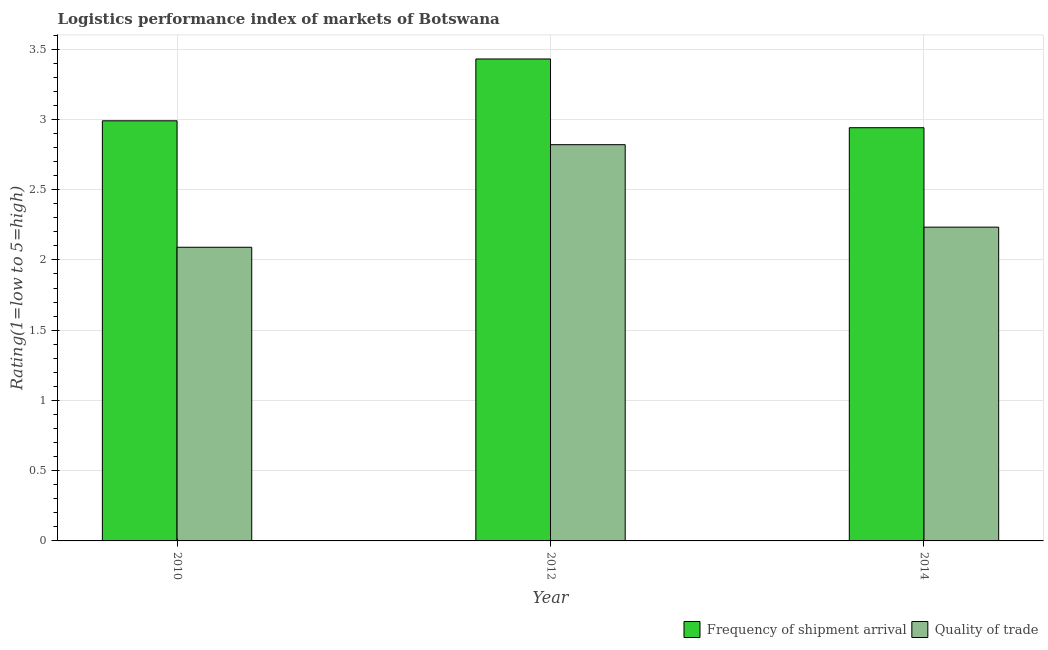How many different coloured bars are there?
Provide a succinct answer. 2. Are the number of bars per tick equal to the number of legend labels?
Your answer should be compact. Yes. Are the number of bars on each tick of the X-axis equal?
Offer a terse response. Yes. How many bars are there on the 3rd tick from the left?
Ensure brevity in your answer.  2. What is the label of the 2nd group of bars from the left?
Make the answer very short. 2012. In how many cases, is the number of bars for a given year not equal to the number of legend labels?
Provide a short and direct response. 0. What is the lpi of frequency of shipment arrival in 2014?
Your answer should be very brief. 2.94. Across all years, what is the maximum lpi of frequency of shipment arrival?
Your response must be concise. 3.43. Across all years, what is the minimum lpi of frequency of shipment arrival?
Your answer should be very brief. 2.94. What is the total lpi of frequency of shipment arrival in the graph?
Make the answer very short. 9.36. What is the difference between the lpi of frequency of shipment arrival in 2012 and that in 2014?
Provide a succinct answer. 0.49. What is the difference between the lpi quality of trade in 2012 and the lpi of frequency of shipment arrival in 2010?
Give a very brief answer. 0.73. What is the average lpi of frequency of shipment arrival per year?
Provide a short and direct response. 3.12. In the year 2014, what is the difference between the lpi of frequency of shipment arrival and lpi quality of trade?
Ensure brevity in your answer.  0. In how many years, is the lpi of frequency of shipment arrival greater than 3?
Make the answer very short. 1. What is the ratio of the lpi quality of trade in 2012 to that in 2014?
Ensure brevity in your answer.  1.26. Is the lpi of frequency of shipment arrival in 2012 less than that in 2014?
Offer a very short reply. No. Is the difference between the lpi of frequency of shipment arrival in 2010 and 2012 greater than the difference between the lpi quality of trade in 2010 and 2012?
Make the answer very short. No. What is the difference between the highest and the second highest lpi quality of trade?
Give a very brief answer. 0.59. What is the difference between the highest and the lowest lpi quality of trade?
Your response must be concise. 0.73. In how many years, is the lpi quality of trade greater than the average lpi quality of trade taken over all years?
Keep it short and to the point. 1. What does the 2nd bar from the left in 2014 represents?
Your response must be concise. Quality of trade. What does the 2nd bar from the right in 2010 represents?
Make the answer very short. Frequency of shipment arrival. How many bars are there?
Offer a very short reply. 6. How many years are there in the graph?
Make the answer very short. 3. How many legend labels are there?
Provide a succinct answer. 2. What is the title of the graph?
Keep it short and to the point. Logistics performance index of markets of Botswana. What is the label or title of the Y-axis?
Your answer should be compact. Rating(1=low to 5=high). What is the Rating(1=low to 5=high) of Frequency of shipment arrival in 2010?
Offer a very short reply. 2.99. What is the Rating(1=low to 5=high) in Quality of trade in 2010?
Offer a very short reply. 2.09. What is the Rating(1=low to 5=high) in Frequency of shipment arrival in 2012?
Ensure brevity in your answer.  3.43. What is the Rating(1=low to 5=high) in Quality of trade in 2012?
Ensure brevity in your answer.  2.82. What is the Rating(1=low to 5=high) in Frequency of shipment arrival in 2014?
Your answer should be compact. 2.94. What is the Rating(1=low to 5=high) in Quality of trade in 2014?
Ensure brevity in your answer.  2.23. Across all years, what is the maximum Rating(1=low to 5=high) in Frequency of shipment arrival?
Make the answer very short. 3.43. Across all years, what is the maximum Rating(1=low to 5=high) in Quality of trade?
Give a very brief answer. 2.82. Across all years, what is the minimum Rating(1=low to 5=high) in Frequency of shipment arrival?
Offer a very short reply. 2.94. Across all years, what is the minimum Rating(1=low to 5=high) in Quality of trade?
Your answer should be very brief. 2.09. What is the total Rating(1=low to 5=high) in Frequency of shipment arrival in the graph?
Offer a terse response. 9.36. What is the total Rating(1=low to 5=high) of Quality of trade in the graph?
Your response must be concise. 7.14. What is the difference between the Rating(1=low to 5=high) of Frequency of shipment arrival in 2010 and that in 2012?
Provide a short and direct response. -0.44. What is the difference between the Rating(1=low to 5=high) in Quality of trade in 2010 and that in 2012?
Make the answer very short. -0.73. What is the difference between the Rating(1=low to 5=high) in Frequency of shipment arrival in 2010 and that in 2014?
Your answer should be very brief. 0.05. What is the difference between the Rating(1=low to 5=high) of Quality of trade in 2010 and that in 2014?
Provide a short and direct response. -0.14. What is the difference between the Rating(1=low to 5=high) of Frequency of shipment arrival in 2012 and that in 2014?
Your answer should be compact. 0.49. What is the difference between the Rating(1=low to 5=high) of Quality of trade in 2012 and that in 2014?
Provide a short and direct response. 0.59. What is the difference between the Rating(1=low to 5=high) in Frequency of shipment arrival in 2010 and the Rating(1=low to 5=high) in Quality of trade in 2012?
Your answer should be compact. 0.17. What is the difference between the Rating(1=low to 5=high) of Frequency of shipment arrival in 2010 and the Rating(1=low to 5=high) of Quality of trade in 2014?
Give a very brief answer. 0.76. What is the difference between the Rating(1=low to 5=high) in Frequency of shipment arrival in 2012 and the Rating(1=low to 5=high) in Quality of trade in 2014?
Your answer should be very brief. 1.2. What is the average Rating(1=low to 5=high) of Frequency of shipment arrival per year?
Ensure brevity in your answer.  3.12. What is the average Rating(1=low to 5=high) in Quality of trade per year?
Provide a succinct answer. 2.38. In the year 2010, what is the difference between the Rating(1=low to 5=high) in Frequency of shipment arrival and Rating(1=low to 5=high) in Quality of trade?
Provide a succinct answer. 0.9. In the year 2012, what is the difference between the Rating(1=low to 5=high) of Frequency of shipment arrival and Rating(1=low to 5=high) of Quality of trade?
Offer a very short reply. 0.61. In the year 2014, what is the difference between the Rating(1=low to 5=high) of Frequency of shipment arrival and Rating(1=low to 5=high) of Quality of trade?
Your answer should be compact. 0.71. What is the ratio of the Rating(1=low to 5=high) of Frequency of shipment arrival in 2010 to that in 2012?
Provide a succinct answer. 0.87. What is the ratio of the Rating(1=low to 5=high) in Quality of trade in 2010 to that in 2012?
Offer a terse response. 0.74. What is the ratio of the Rating(1=low to 5=high) of Frequency of shipment arrival in 2010 to that in 2014?
Provide a succinct answer. 1.02. What is the ratio of the Rating(1=low to 5=high) of Quality of trade in 2010 to that in 2014?
Offer a very short reply. 0.94. What is the ratio of the Rating(1=low to 5=high) of Frequency of shipment arrival in 2012 to that in 2014?
Offer a very short reply. 1.17. What is the ratio of the Rating(1=low to 5=high) in Quality of trade in 2012 to that in 2014?
Keep it short and to the point. 1.26. What is the difference between the highest and the second highest Rating(1=low to 5=high) of Frequency of shipment arrival?
Provide a succinct answer. 0.44. What is the difference between the highest and the second highest Rating(1=low to 5=high) in Quality of trade?
Your answer should be very brief. 0.59. What is the difference between the highest and the lowest Rating(1=low to 5=high) of Frequency of shipment arrival?
Offer a terse response. 0.49. What is the difference between the highest and the lowest Rating(1=low to 5=high) in Quality of trade?
Make the answer very short. 0.73. 